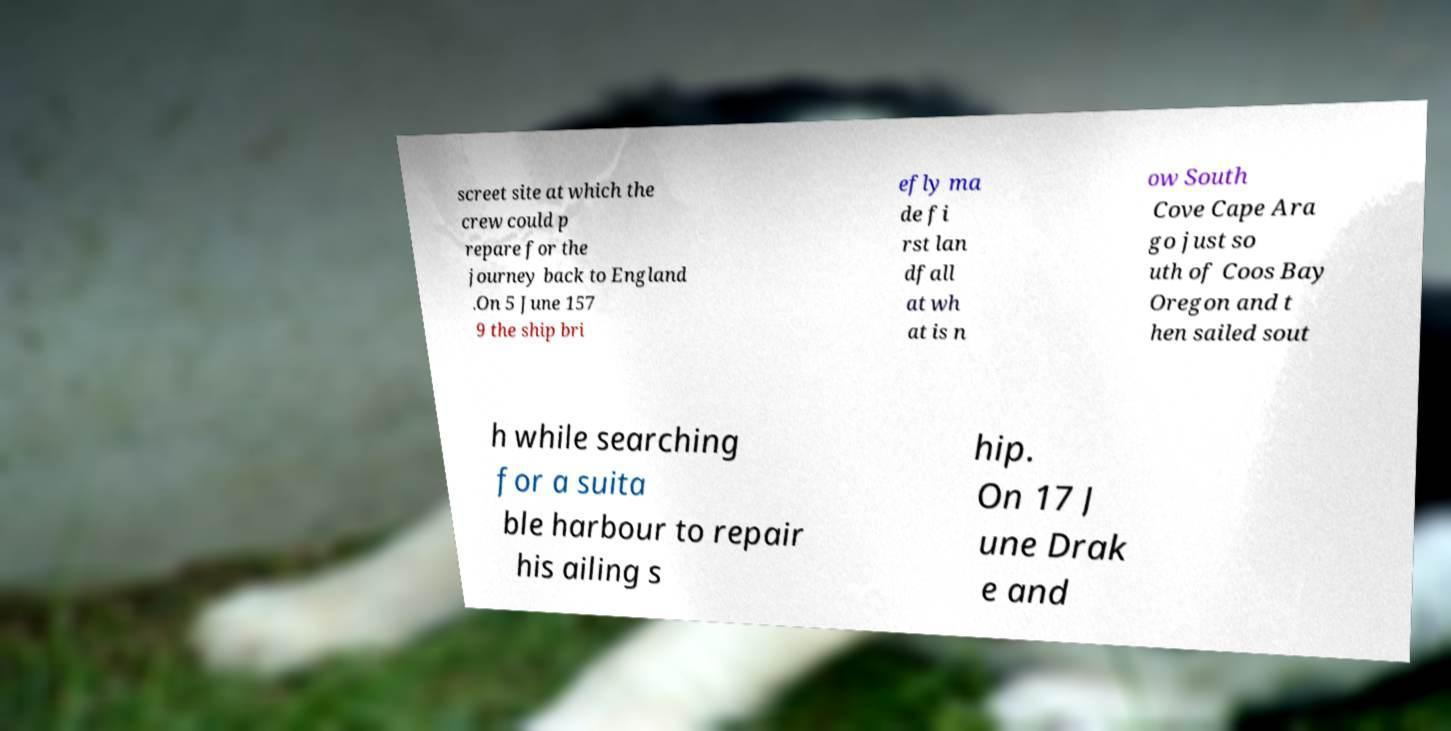Can you accurately transcribe the text from the provided image for me? screet site at which the crew could p repare for the journey back to England .On 5 June 157 9 the ship bri efly ma de fi rst lan dfall at wh at is n ow South Cove Cape Ara go just so uth of Coos Bay Oregon and t hen sailed sout h while searching for a suita ble harbour to repair his ailing s hip. On 17 J une Drak e and 